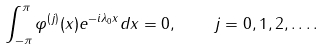<formula> <loc_0><loc_0><loc_500><loc_500>\int _ { - \pi } ^ { \pi } \varphi ^ { ( j ) } ( x ) e ^ { - i \lambda _ { 0 } x } d x = 0 , \quad j = 0 , 1 , 2 , \dots .</formula> 